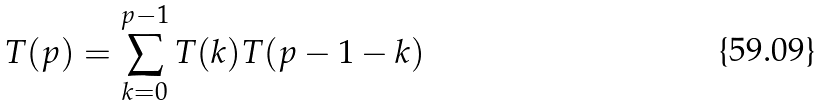<formula> <loc_0><loc_0><loc_500><loc_500>T ( p ) = \sum _ { k = 0 } ^ { p - 1 } T ( k ) T ( p - 1 - k )</formula> 